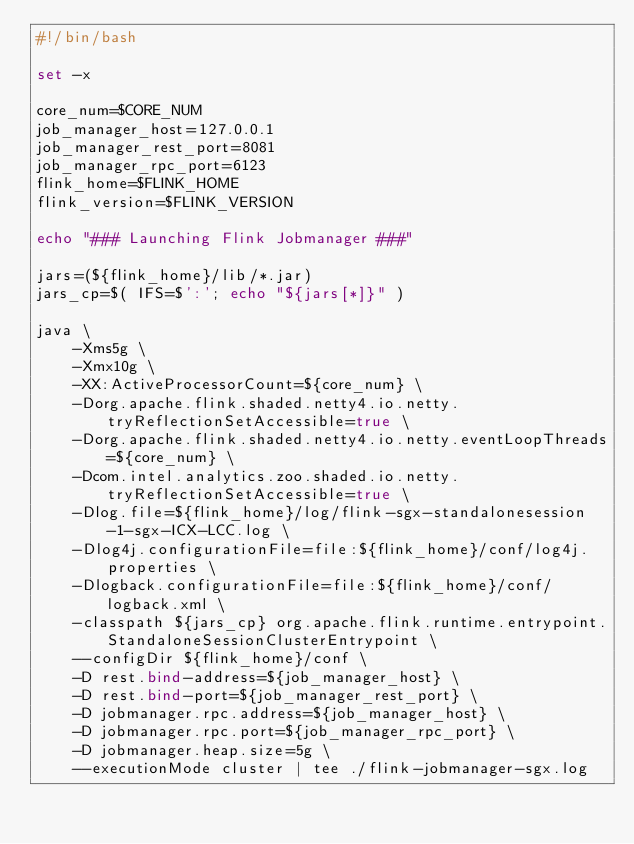Convert code to text. <code><loc_0><loc_0><loc_500><loc_500><_Bash_>#!/bin/bash

set -x

core_num=$CORE_NUM
job_manager_host=127.0.0.1
job_manager_rest_port=8081
job_manager_rpc_port=6123
flink_home=$FLINK_HOME
flink_version=$FLINK_VERSION

echo "### Launching Flink Jobmanager ###"

jars=(${flink_home}/lib/*.jar)
jars_cp=$( IFS=$':'; echo "${jars[*]}" )

java \
    -Xms5g \
    -Xmx10g \
    -XX:ActiveProcessorCount=${core_num} \
    -Dorg.apache.flink.shaded.netty4.io.netty.tryReflectionSetAccessible=true \
    -Dorg.apache.flink.shaded.netty4.io.netty.eventLoopThreads=${core_num} \
    -Dcom.intel.analytics.zoo.shaded.io.netty.tryReflectionSetAccessible=true \
    -Dlog.file=${flink_home}/log/flink-sgx-standalonesession-1-sgx-ICX-LCC.log \
    -Dlog4j.configurationFile=file:${flink_home}/conf/log4j.properties \
    -Dlogback.configurationFile=file:${flink_home}/conf/logback.xml \
    -classpath ${jars_cp} org.apache.flink.runtime.entrypoint.StandaloneSessionClusterEntrypoint \
    --configDir ${flink_home}/conf \
    -D rest.bind-address=${job_manager_host} \
    -D rest.bind-port=${job_manager_rest_port} \
    -D jobmanager.rpc.address=${job_manager_host} \
    -D jobmanager.rpc.port=${job_manager_rpc_port} \
    -D jobmanager.heap.size=5g \
    --executionMode cluster | tee ./flink-jobmanager-sgx.log

</code> 